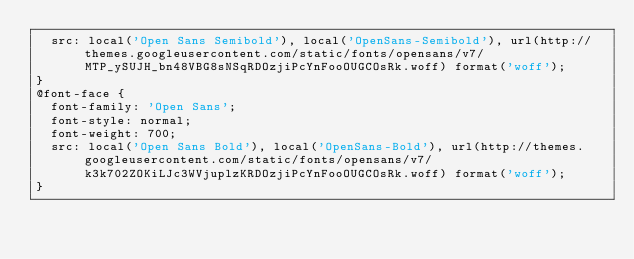<code> <loc_0><loc_0><loc_500><loc_500><_CSS_>  src: local('Open Sans Semibold'), local('OpenSans-Semibold'), url(http://themes.googleusercontent.com/static/fonts/opensans/v7/MTP_ySUJH_bn48VBG8sNSqRDOzjiPcYnFooOUGCOsRk.woff) format('woff');
}
@font-face {
  font-family: 'Open Sans';
  font-style: normal;
  font-weight: 700;
  src: local('Open Sans Bold'), local('OpenSans-Bold'), url(http://themes.googleusercontent.com/static/fonts/opensans/v7/k3k702ZOKiLJc3WVjuplzKRDOzjiPcYnFooOUGCOsRk.woff) format('woff');
}
</code> 